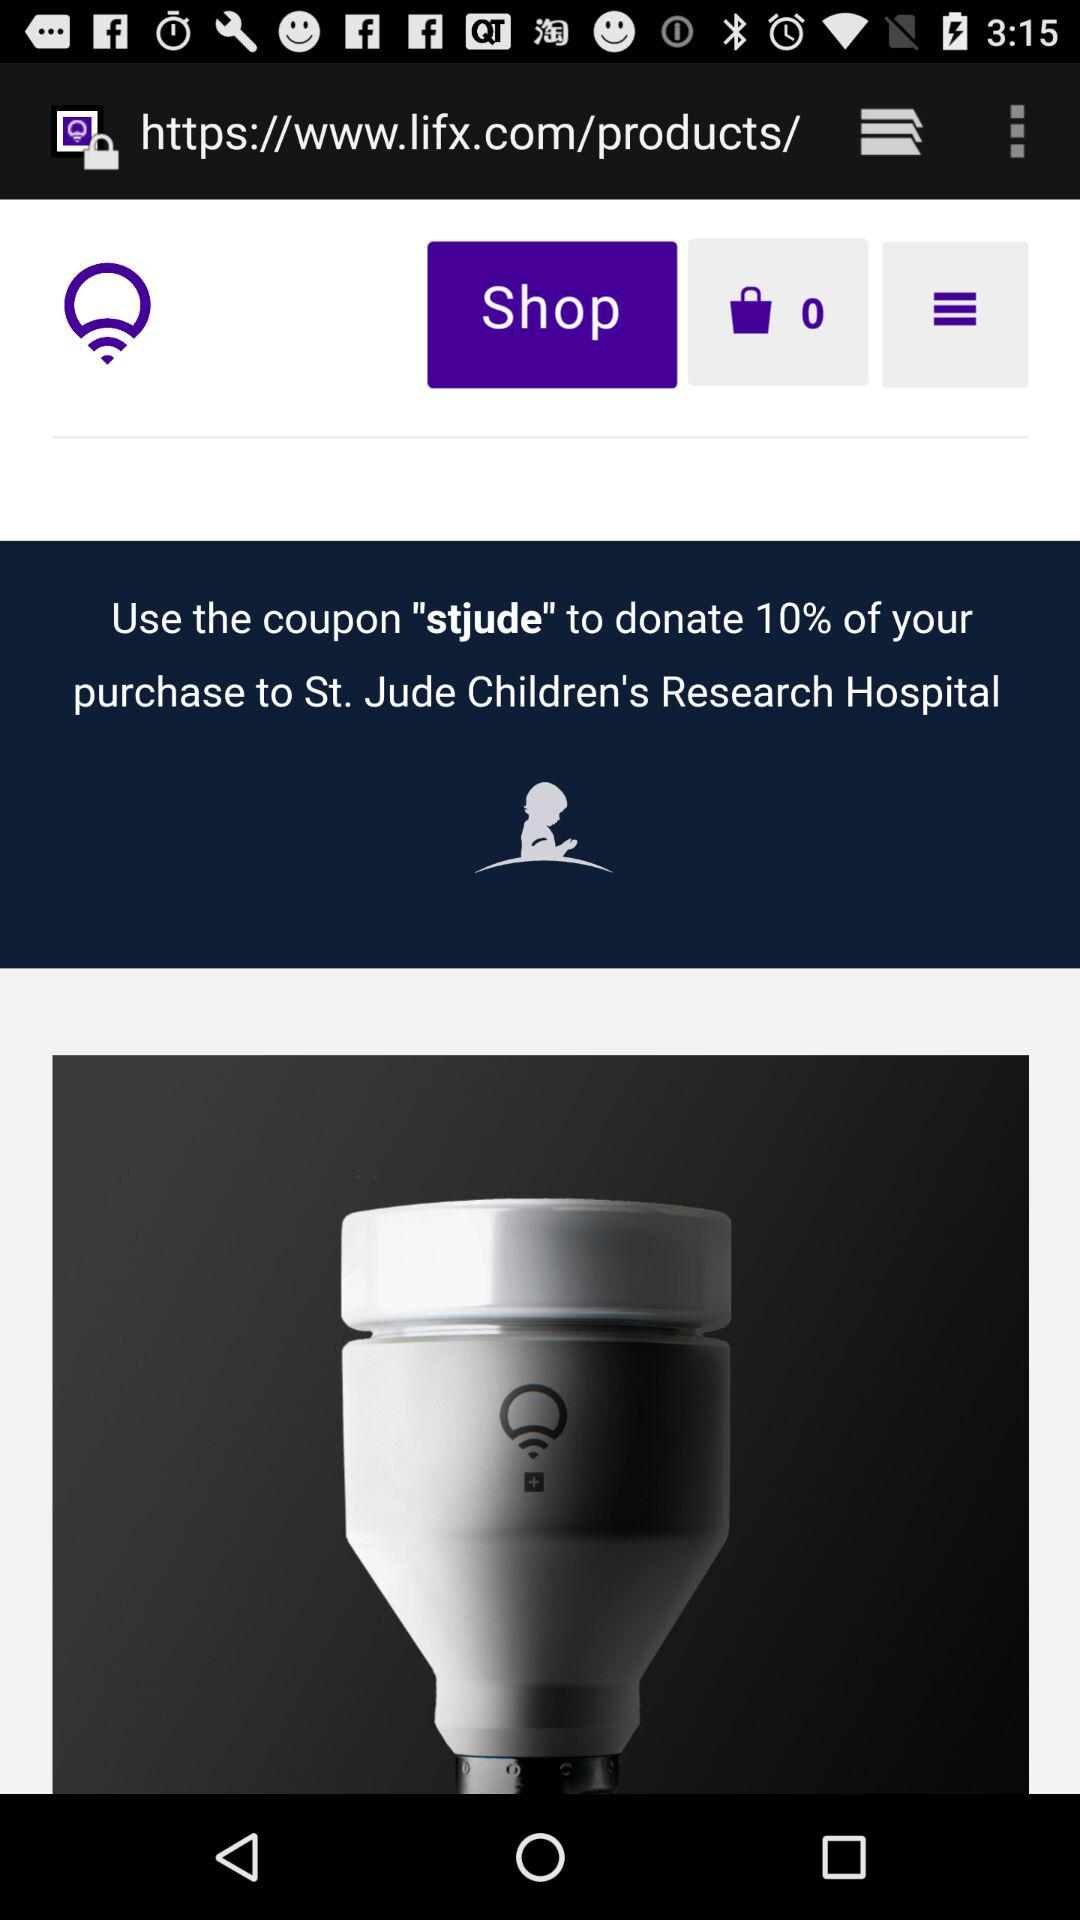Who is this application powered by?
When the provided information is insufficient, respond with <no answer>. <no answer> 